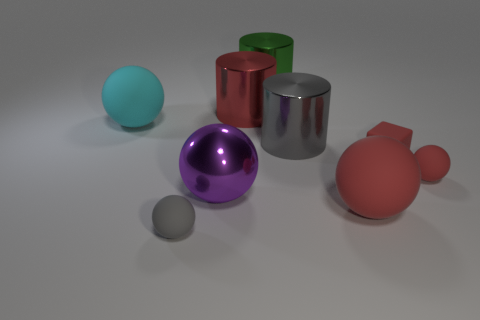There is a big cylinder that is the same color as the rubber cube; what is its material?
Provide a short and direct response. Metal. What number of other things are the same color as the metal ball?
Keep it short and to the point. 0. Does the rubber sphere that is behind the large gray thing have the same size as the cylinder behind the red cylinder?
Your answer should be compact. Yes. How big is the gray object that is behind the small ball to the right of the red matte block?
Offer a terse response. Large. What is the material of the big ball that is left of the big green metallic cylinder and in front of the big cyan rubber thing?
Your response must be concise. Metal. What is the color of the big metal ball?
Your answer should be very brief. Purple. There is a small thing that is on the left side of the big purple metal ball; what shape is it?
Provide a short and direct response. Sphere. There is a red matte sphere that is in front of the matte sphere on the right side of the red rubber cube; are there any purple shiny spheres on the left side of it?
Your response must be concise. Yes. Are there any other things that have the same shape as the gray matte object?
Your answer should be compact. Yes. Are there any yellow objects?
Keep it short and to the point. No. 